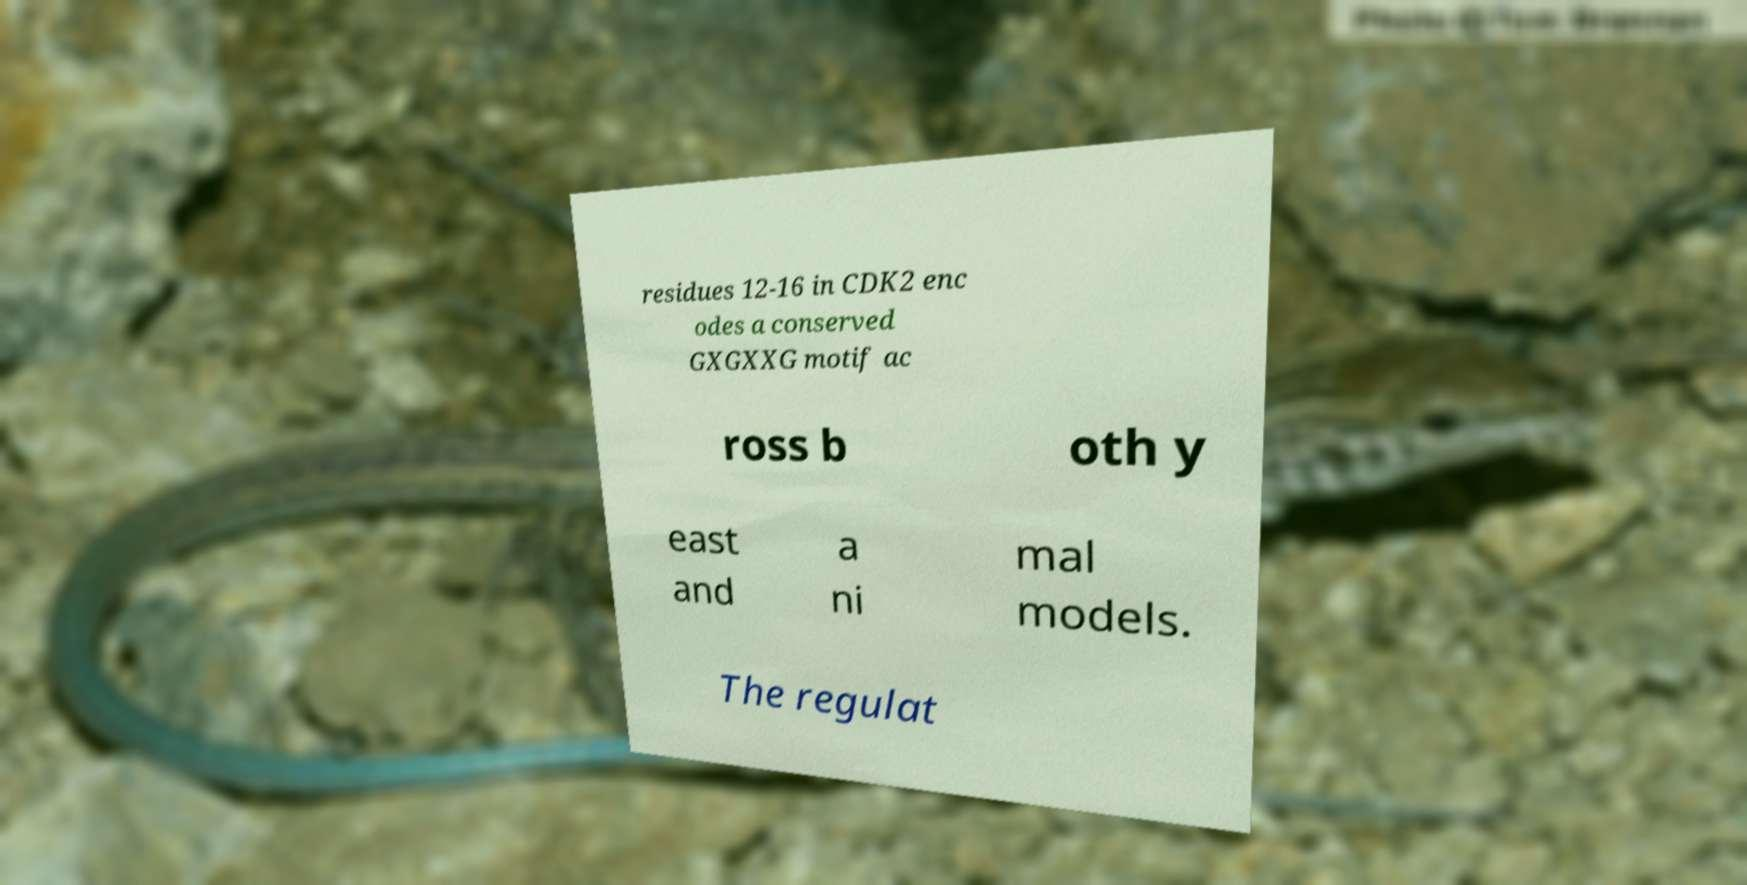Please identify and transcribe the text found in this image. residues 12-16 in CDK2 enc odes a conserved GXGXXG motif ac ross b oth y east and a ni mal models. The regulat 